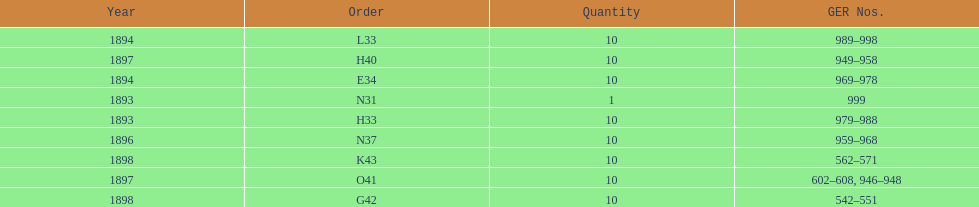How many years are listed? 5. 